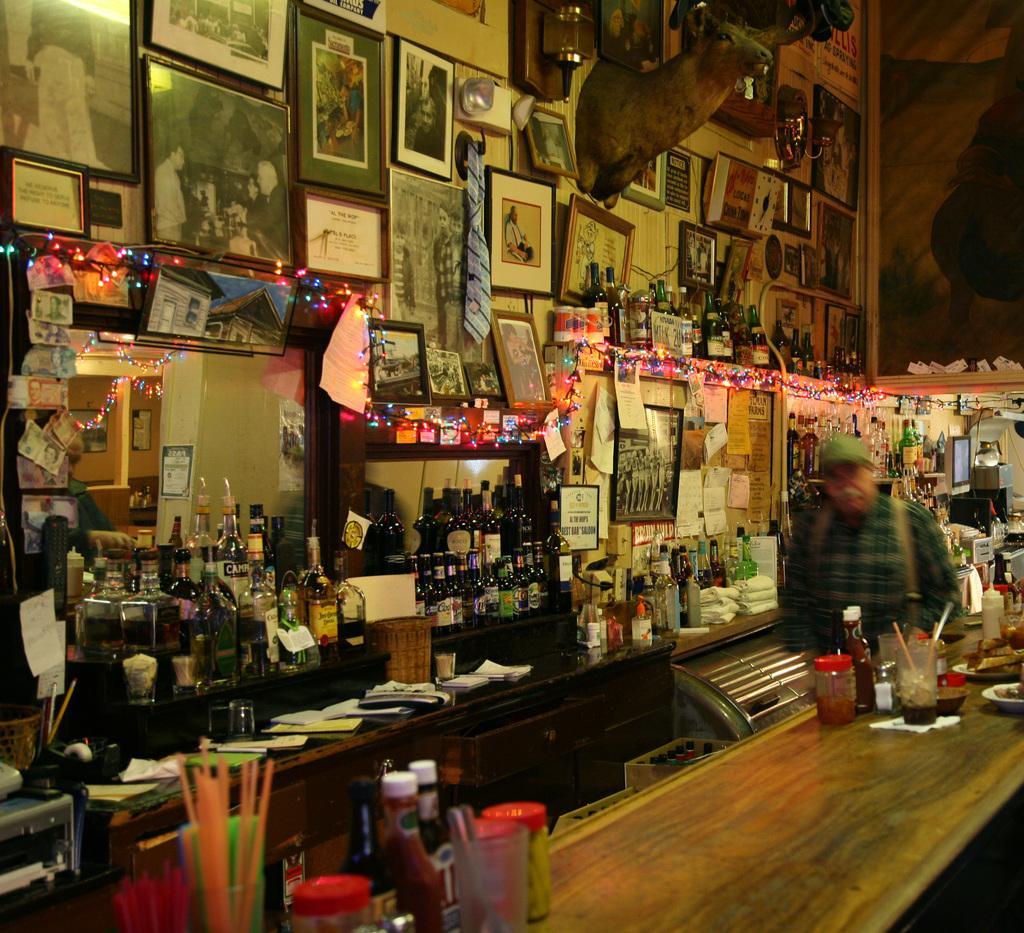Please provide a concise description of this image. In this image we can see a person standing beside a table containing some straws in a glass, some bottles, containers, plates and some papers on it. On the backside we can see a group of photo frames and a decor hanged to a wall. We can also see a towel, a lamp, candles with flame, some lights and some papers and notes which are pasted on a wall. We can also see a group of bottles placed beside the table. 